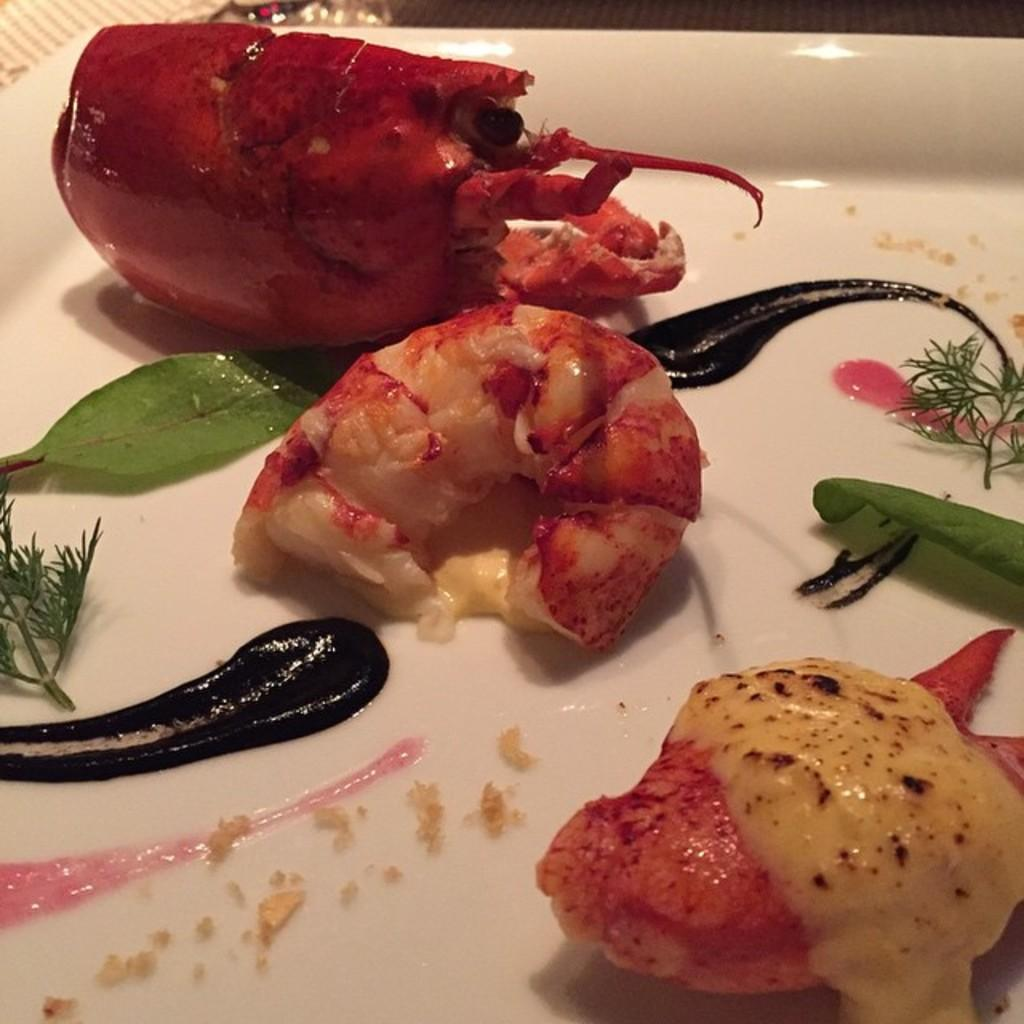What type of food can be seen in the image? The food in the image is in red and cream colors. How is the food arranged in the image? The food is on a plate in the image. What color is the plate? The plate is white. What type of key is used to unlock the fowl in the image? There is no key or fowl present in the image; it only features food on a plate. Is there any reading material visible in the image? There is no reading material present in the image; it only features food on a plate. 